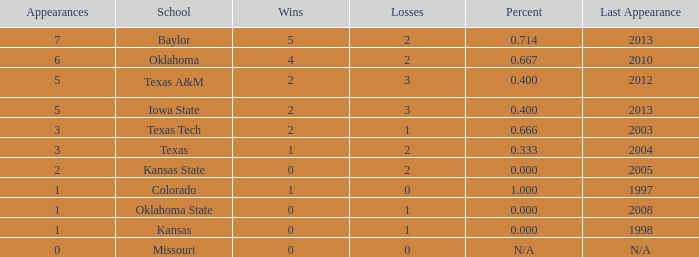How many schools maintained a 1.0. 